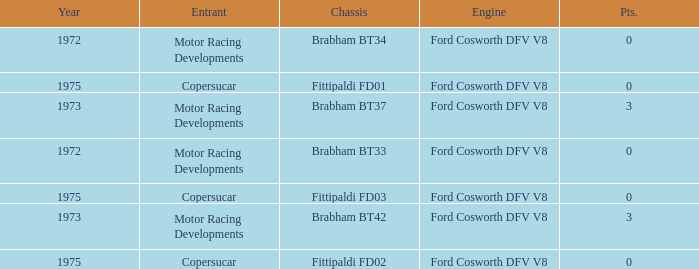Which chassis is more recent than 1972 and has more than 0 Pts. ? Brabham BT37, Brabham BT42. 